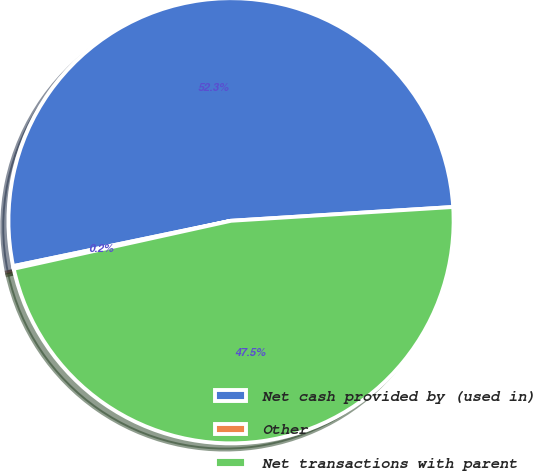Convert chart. <chart><loc_0><loc_0><loc_500><loc_500><pie_chart><fcel>Net cash provided by (used in)<fcel>Other<fcel>Net transactions with parent<nl><fcel>52.28%<fcel>0.19%<fcel>47.53%<nl></chart> 